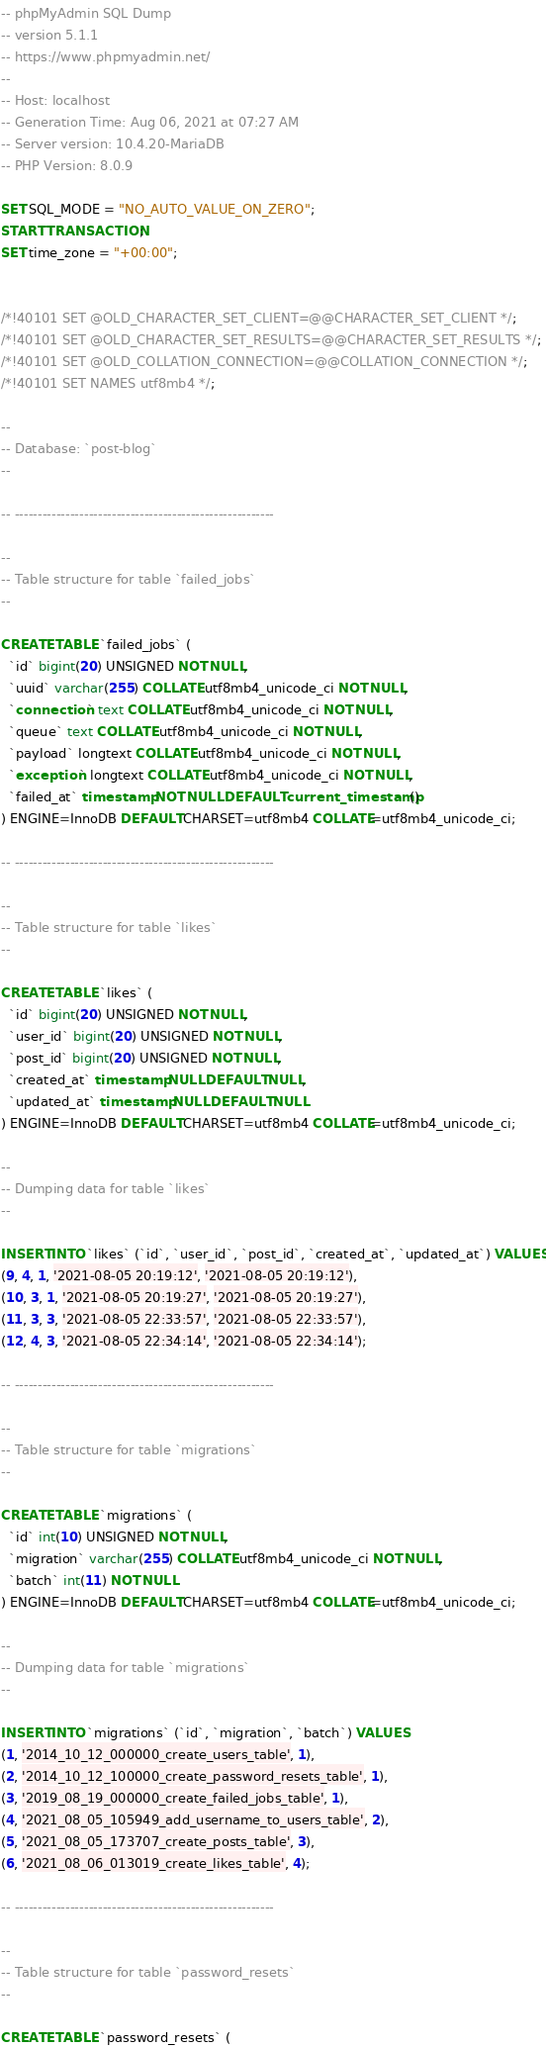Convert code to text. <code><loc_0><loc_0><loc_500><loc_500><_SQL_>-- phpMyAdmin SQL Dump
-- version 5.1.1
-- https://www.phpmyadmin.net/
--
-- Host: localhost
-- Generation Time: Aug 06, 2021 at 07:27 AM
-- Server version: 10.4.20-MariaDB
-- PHP Version: 8.0.9

SET SQL_MODE = "NO_AUTO_VALUE_ON_ZERO";
START TRANSACTION;
SET time_zone = "+00:00";


/*!40101 SET @OLD_CHARACTER_SET_CLIENT=@@CHARACTER_SET_CLIENT */;
/*!40101 SET @OLD_CHARACTER_SET_RESULTS=@@CHARACTER_SET_RESULTS */;
/*!40101 SET @OLD_COLLATION_CONNECTION=@@COLLATION_CONNECTION */;
/*!40101 SET NAMES utf8mb4 */;

--
-- Database: `post-blog`
--

-- --------------------------------------------------------

--
-- Table structure for table `failed_jobs`
--

CREATE TABLE `failed_jobs` (
  `id` bigint(20) UNSIGNED NOT NULL,
  `uuid` varchar(255) COLLATE utf8mb4_unicode_ci NOT NULL,
  `connection` text COLLATE utf8mb4_unicode_ci NOT NULL,
  `queue` text COLLATE utf8mb4_unicode_ci NOT NULL,
  `payload` longtext COLLATE utf8mb4_unicode_ci NOT NULL,
  `exception` longtext COLLATE utf8mb4_unicode_ci NOT NULL,
  `failed_at` timestamp NOT NULL DEFAULT current_timestamp()
) ENGINE=InnoDB DEFAULT CHARSET=utf8mb4 COLLATE=utf8mb4_unicode_ci;

-- --------------------------------------------------------

--
-- Table structure for table `likes`
--

CREATE TABLE `likes` (
  `id` bigint(20) UNSIGNED NOT NULL,
  `user_id` bigint(20) UNSIGNED NOT NULL,
  `post_id` bigint(20) UNSIGNED NOT NULL,
  `created_at` timestamp NULL DEFAULT NULL,
  `updated_at` timestamp NULL DEFAULT NULL
) ENGINE=InnoDB DEFAULT CHARSET=utf8mb4 COLLATE=utf8mb4_unicode_ci;

--
-- Dumping data for table `likes`
--

INSERT INTO `likes` (`id`, `user_id`, `post_id`, `created_at`, `updated_at`) VALUES
(9, 4, 1, '2021-08-05 20:19:12', '2021-08-05 20:19:12'),
(10, 3, 1, '2021-08-05 20:19:27', '2021-08-05 20:19:27'),
(11, 3, 3, '2021-08-05 22:33:57', '2021-08-05 22:33:57'),
(12, 4, 3, '2021-08-05 22:34:14', '2021-08-05 22:34:14');

-- --------------------------------------------------------

--
-- Table structure for table `migrations`
--

CREATE TABLE `migrations` (
  `id` int(10) UNSIGNED NOT NULL,
  `migration` varchar(255) COLLATE utf8mb4_unicode_ci NOT NULL,
  `batch` int(11) NOT NULL
) ENGINE=InnoDB DEFAULT CHARSET=utf8mb4 COLLATE=utf8mb4_unicode_ci;

--
-- Dumping data for table `migrations`
--

INSERT INTO `migrations` (`id`, `migration`, `batch`) VALUES
(1, '2014_10_12_000000_create_users_table', 1),
(2, '2014_10_12_100000_create_password_resets_table', 1),
(3, '2019_08_19_000000_create_failed_jobs_table', 1),
(4, '2021_08_05_105949_add_username_to_users_table', 2),
(5, '2021_08_05_173707_create_posts_table', 3),
(6, '2021_08_06_013019_create_likes_table', 4);

-- --------------------------------------------------------

--
-- Table structure for table `password_resets`
--

CREATE TABLE `password_resets` (</code> 